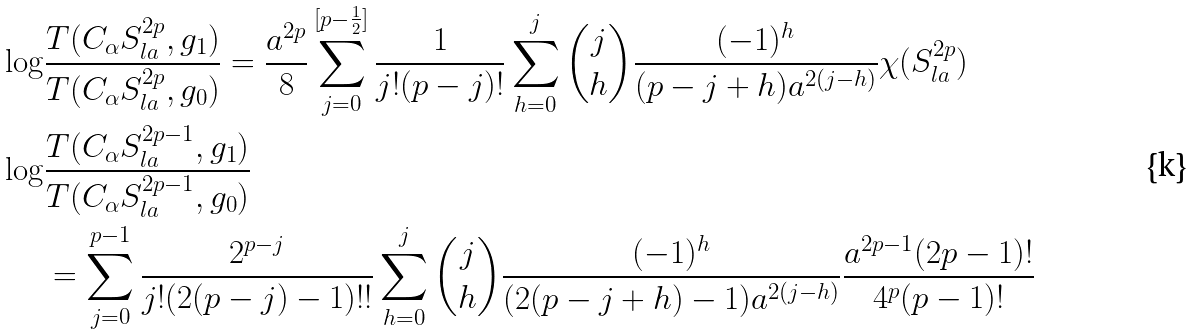<formula> <loc_0><loc_0><loc_500><loc_500>\log & \frac { T ( C _ { \alpha } S ^ { 2 p } _ { l a } , g _ { 1 } ) } { T ( C _ { \alpha } S ^ { 2 p } _ { l a } , g _ { 0 } ) } = \frac { a ^ { 2 p } } { 8 } \sum _ { j = 0 } ^ { [ p - \frac { 1 } { 2 } ] } \frac { 1 } { j ! ( p - j ) ! } \sum _ { h = 0 } ^ { j } \binom { j } { h } \frac { ( - 1 ) ^ { h } } { ( p - j + h ) a ^ { 2 ( j - h ) } } \chi ( S ^ { 2 p } _ { l a } ) \\ \log & \frac { T ( C _ { \alpha } S ^ { 2 p - 1 } _ { l a } , g _ { 1 } ) } { T ( C _ { \alpha } S ^ { 2 p - 1 } _ { l a } , g _ { 0 } ) } \\ & = \sum _ { j = 0 } ^ { p - 1 } \frac { 2 ^ { p - j } } { j ! ( 2 ( p - j ) - 1 ) ! ! } \sum _ { h = 0 } ^ { j } \binom { j } { h } \frac { ( - 1 ) ^ { h } } { ( 2 ( p - j + h ) - 1 ) a ^ { 2 ( j - h ) } } \frac { a ^ { 2 p - 1 } ( 2 p - 1 ) ! } { 4 ^ { p } ( p - 1 ) ! }</formula> 